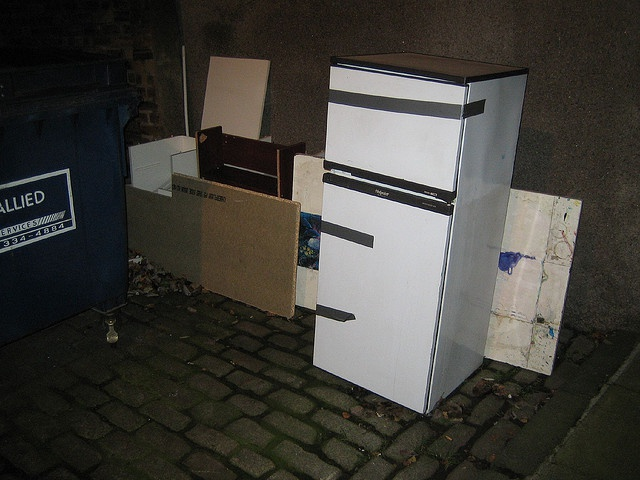Describe the objects in this image and their specific colors. I can see a refrigerator in black, lightgray, gray, and darkgray tones in this image. 